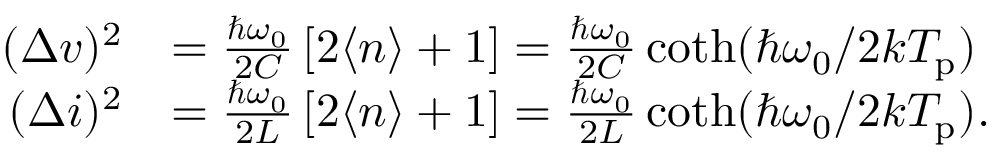<formula> <loc_0><loc_0><loc_500><loc_500>\begin{array} { r l } { ( \Delta v ) ^ { 2 } } & { = \frac { \hbar { \omega } _ { 0 } } { 2 C } \left [ 2 \langle n \rangle + 1 \right ] = \frac { \hbar { \omega } _ { 0 } } { 2 C } \coth ( \hbar { \omega } _ { 0 } / 2 k T _ { p } ) } \\ { ( \Delta i ) ^ { 2 } } & { = \frac { \hbar { \omega } _ { 0 } } { 2 L } \left [ 2 \langle n \rangle + 1 \right ] = \frac { \hbar { \omega } _ { 0 } } { 2 L } \coth ( \hbar { \omega } _ { 0 } / 2 k T _ { p } ) . } \end{array}</formula> 